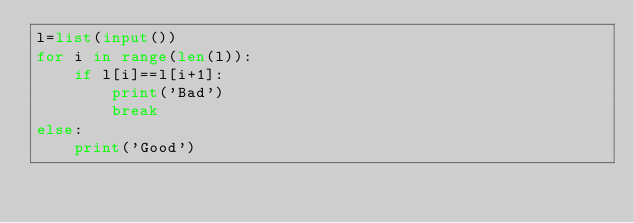Convert code to text. <code><loc_0><loc_0><loc_500><loc_500><_Python_>l=list(input())
for i in range(len(l)):
    if l[i]==l[i+1]:
        print('Bad')
        break
else:
    print('Good')</code> 